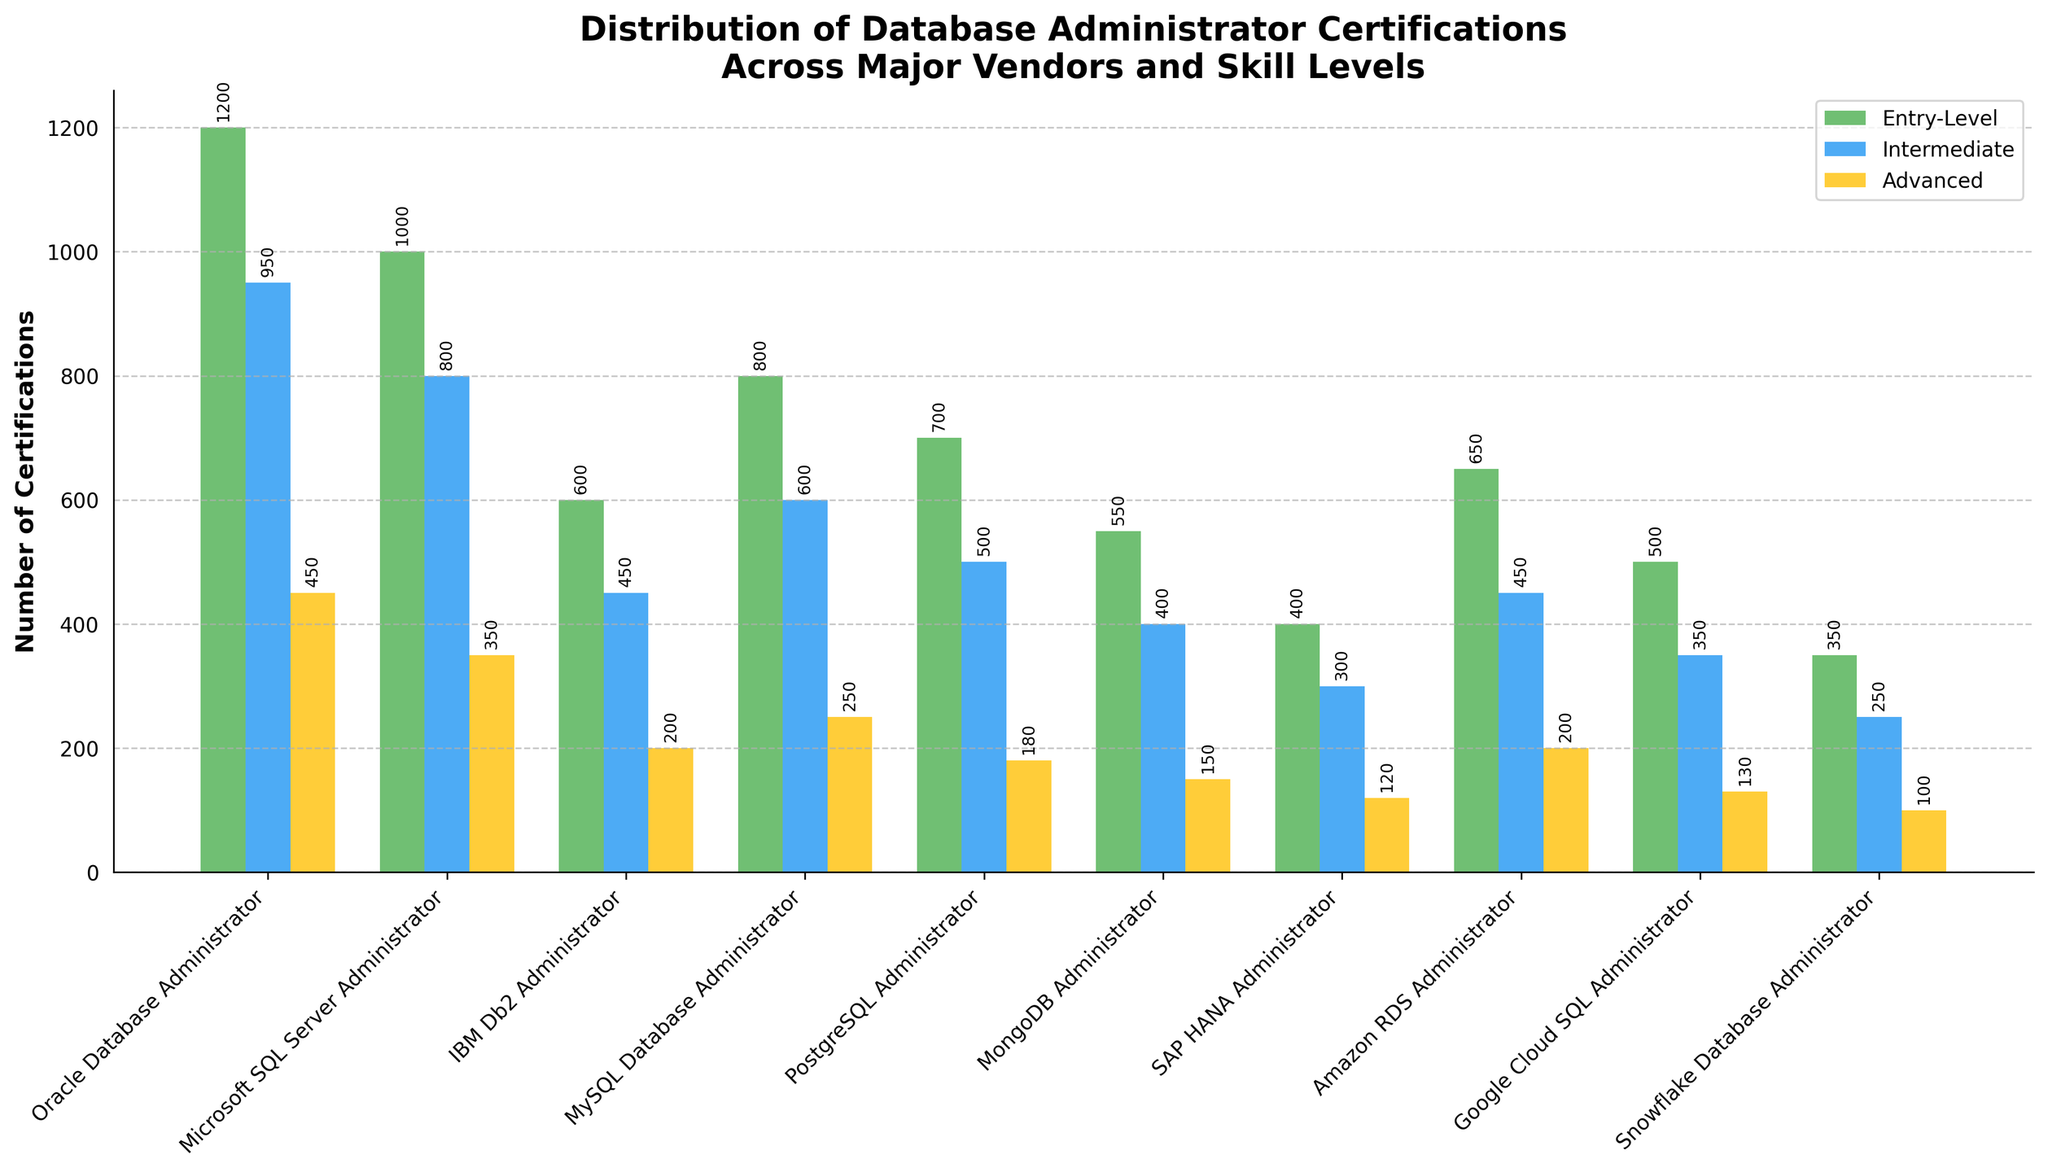Which certification has the highest number of entry-level certifications? Look for the tallest green bar, which represents entry-level certifications. Oracle Database Administrator has the tallest green bar.
Answer: Oracle Database Administrator Which certification has the lowest number of advanced certifications? Look for the shortest yellow bar, which represents advanced certifications. Snowflake Database Administrator has the shortest yellow bar.
Answer: Snowflake Database Administrator How many intermediate certifications are there for Microsoft SQL Server Administrator and PostgreSQL Administrator combined? Sum the heights of the blue bars for Microsoft SQL Server Administrator (800) and PostgreSQL Administrator (500).
Answer: 1300 Compare the number of advanced certifications for IBM Db2 Administrator and Google Cloud SQL Administrator. Which one has more? Compare the heights of the yellow bars for IBM Db2 Administrator (200) and Google Cloud SQL Administrator (130). IBM Db2 Administrator has a taller yellow bar.
Answer: IBM Db2 Administrator What is the total number of Oracle Database Administrator certifications across all skill levels? Sum the heights of all bars for Oracle Database Administrator: 1200 (green) + 950 (blue) + 450 (yellow).
Answer: 2600 Which certification has a higher number of intermediate certifications: MySQL Database Administrator or Amazon RDS Administrator? Compare the heights of the blue bars for MySQL Database Administrator (600) and Amazon RDS Administrator (450). MySQL Database Administrator has a taller blue bar.
Answer: MySQL Database Administrator What is the difference in the number of entry-level certifications between MongoDB Administrator and SAP HANA Administrator? Subtract the number of entry-level certifications for SAP HANA Administrator (400) from MongoDB Administrator (550).
Answer: 150 Which certification shows a consistent decrease in the number of certifications from entry-level to advanced? Look for the one where the green bar is taller than the blue, and the blue is taller than the yellow. SAP HANA Administrator shows this consistent decrease: 400 (green) > 300 (blue) > 120 (yellow).
Answer: SAP HANA Administrator How many advanced certifications are there for Oracle Database Administrator compared to Microsoft SQL Server Administrator? Compare the heights of the yellow bars for Oracle Database Administrator (450) and Microsoft SQL Server Administrator (350). Oracle Database Administrator has more advanced certifications.
Answer: Oracle Database Administrator 